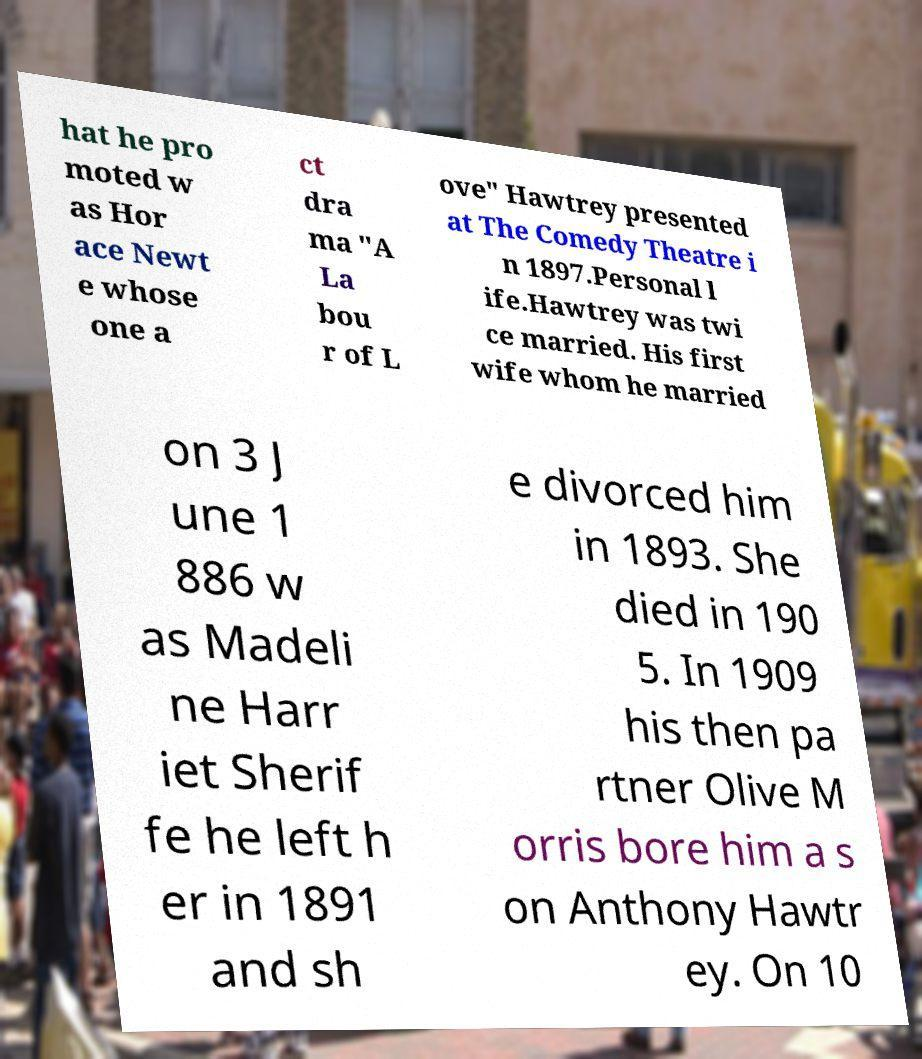I need the written content from this picture converted into text. Can you do that? hat he pro moted w as Hor ace Newt e whose one a ct dra ma "A La bou r of L ove" Hawtrey presented at The Comedy Theatre i n 1897.Personal l ife.Hawtrey was twi ce married. His first wife whom he married on 3 J une 1 886 w as Madeli ne Harr iet Sherif fe he left h er in 1891 and sh e divorced him in 1893. She died in 190 5. In 1909 his then pa rtner Olive M orris bore him a s on Anthony Hawtr ey. On 10 